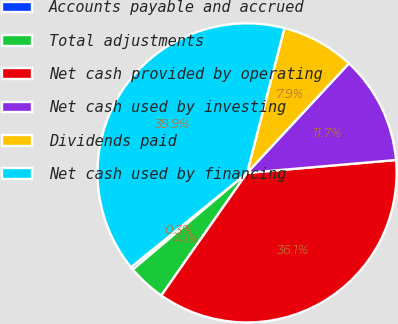<chart> <loc_0><loc_0><loc_500><loc_500><pie_chart><fcel>Accounts payable and accrued<fcel>Total adjustments<fcel>Net cash provided by operating<fcel>Net cash used by investing<fcel>Dividends paid<fcel>Net cash used by financing<nl><fcel>0.31%<fcel>4.11%<fcel>36.09%<fcel>11.7%<fcel>7.91%<fcel>39.89%<nl></chart> 